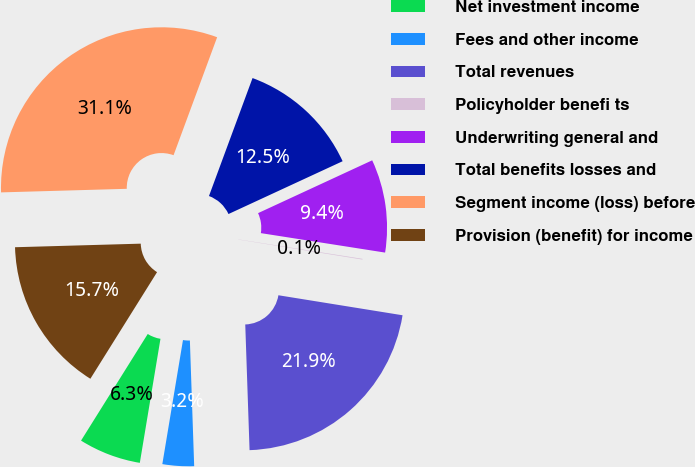<chart> <loc_0><loc_0><loc_500><loc_500><pie_chart><fcel>Net investment income<fcel>Fees and other income<fcel>Total revenues<fcel>Policyholder benefi ts<fcel>Underwriting general and<fcel>Total benefits losses and<fcel>Segment income (loss) before<fcel>Provision (benefit) for income<nl><fcel>6.27%<fcel>3.17%<fcel>21.91%<fcel>0.07%<fcel>9.37%<fcel>12.47%<fcel>31.08%<fcel>15.65%<nl></chart> 